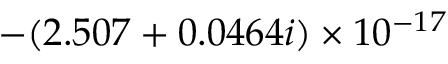Convert formula to latex. <formula><loc_0><loc_0><loc_500><loc_500>- ( 2 . 5 0 7 + 0 . 0 4 6 4 i ) \times 1 0 ^ { - 1 7 }</formula> 